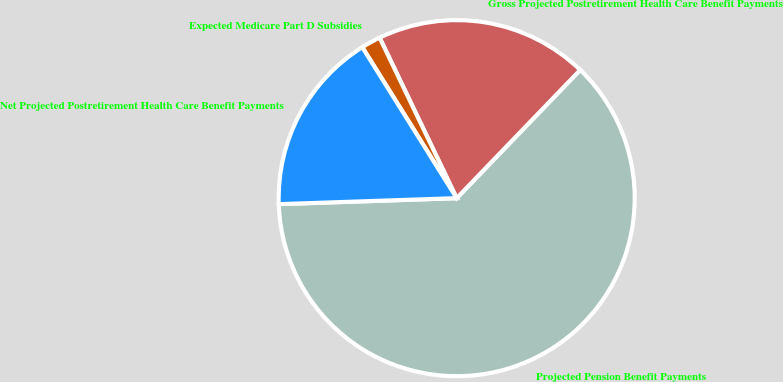<chart> <loc_0><loc_0><loc_500><loc_500><pie_chart><fcel>Projected Pension Benefit Payments<fcel>Gross Projected Postretirement Health Care Benefit Payments<fcel>Expected Medicare Part D Subsidies<fcel>Net Projected Postretirement Health Care Benefit Payments<nl><fcel>62.26%<fcel>19.33%<fcel>1.77%<fcel>16.64%<nl></chart> 